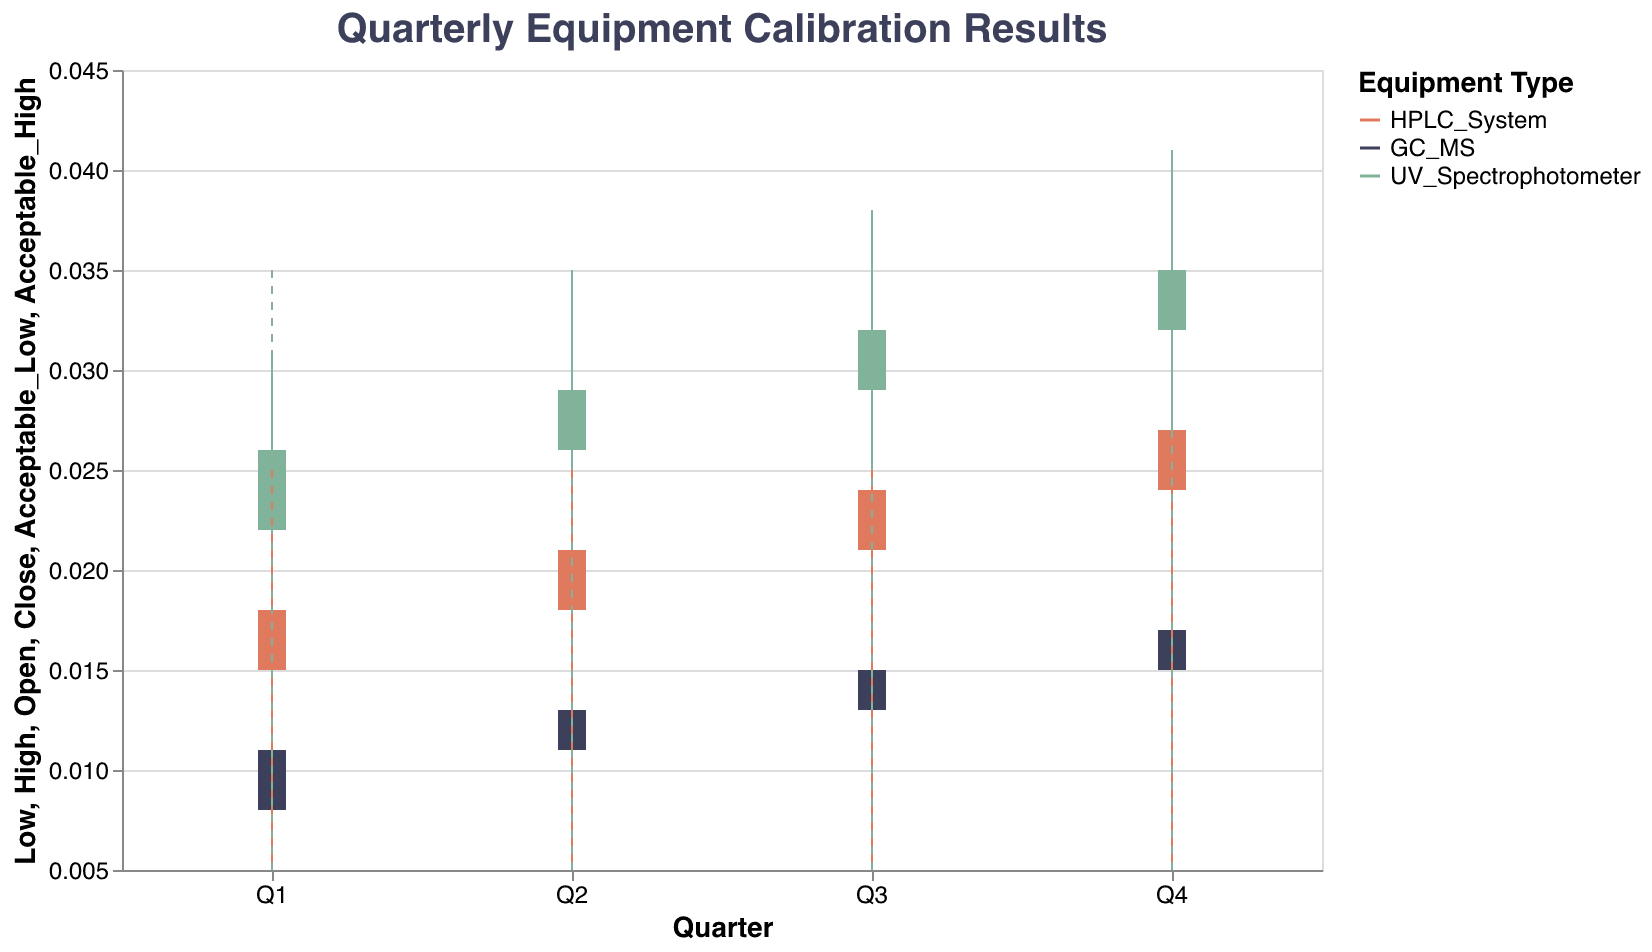What is the title of the figure? The title of the figure is usually displayed at the top and describes what the chart is about.
Answer: Quarterly Equipment Calibration Results Which equipment had the highest 'Close' value in Q2? By observing the 'Close' values for Q2, we compare the values for each equipment.
Answer: UV_Spectrophotometer What is the range of 'High' values for the HPLC System in Q4? For the HPLC System in Q4, we look at the 'Low' and 'High' values to find the range.
Answer: 0.019 to 0.031 Which equipment consistently falls within the acceptable error range across all quarters? We compare the 'High' and 'Low' values with the 'Acceptable_High' and 'Acceptable_Low' lines across all quarters for each equipment.
Answer: UV_Spectrophotometer Was the 'Open' value for the GC-MS in Q4 within the acceptable range? We check if the 'Open' value in Q4 for the GC-MS is between the acceptable low and high limits.
Answer: Yes For HPLC System, which quarter shows the greatest variation between 'High' and 'Low'? Variation is calculated as 'High' minus 'Low'; we compare these variations across quarters for the HPLC System.
Answer: Q3 How did the 'Close' values for the UV Spectrophotometer change from Q2 to Q3? We observe the 'Close' values for UV Spectrophotometer in Q2 and Q3 and note the change.
Answer: Increase by 0.003 Compare the 'High' values of the HPLC System and UV Spectrophotometer in Q1. Which one is higher? By comparing the 'High' values of both instruments in Q1, we determine which one is higher.
Answer: UV_Spectrophotometer What was the 'Close' value for the GC-MS in Q1 and how does it compare to the acceptable range? We look at the 'Close' value for GC-MS in Q1 and check if it falls within the acceptable high and low limits.
Answer: Within range, 0.011 